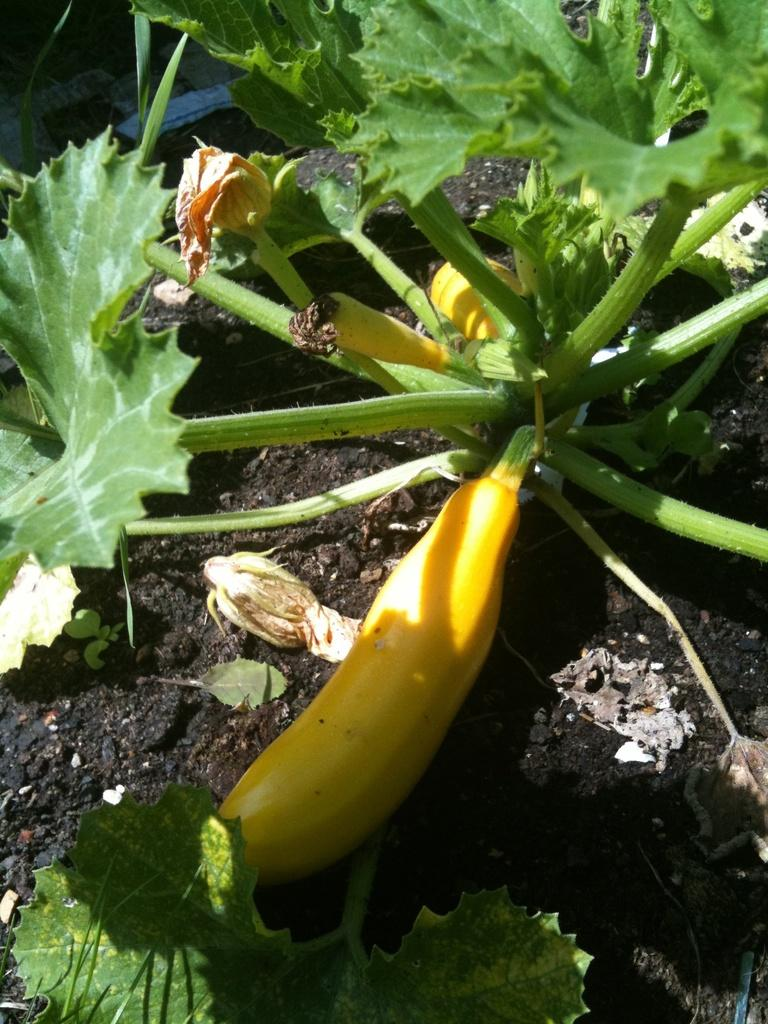What type of plant is in the image? There is a vegetable plant in the image. What features can be seen on the vegetable plant? The vegetable plant has leaves. On what surface is the vegetable plant placed? The vegetable plant is on a surface. Who is the creator of the airplane in the image? There is no airplane present in the image, so it is not possible to determine the creator. 